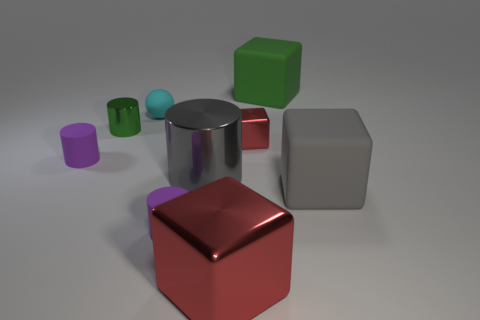What is the cyan object made of?
Keep it short and to the point. Rubber. What number of tiny rubber objects are the same shape as the green metal object?
Provide a short and direct response. 2. What material is the thing that is the same color as the big metallic cylinder?
Offer a terse response. Rubber. Is there anything else that is the same shape as the cyan object?
Provide a short and direct response. No. There is a large cube behind the metal cube behind the small purple rubber object to the left of the tiny rubber sphere; what is its color?
Keep it short and to the point. Green. How many tiny objects are either gray metallic balls or green shiny objects?
Keep it short and to the point. 1. Are there the same number of objects on the left side of the small cyan ball and matte blocks?
Your answer should be very brief. Yes. Are there any cylinders on the right side of the cyan ball?
Give a very brief answer. Yes. What number of metal things are either small purple cubes or big blocks?
Your answer should be compact. 1. There is a large gray cylinder; what number of gray things are on the right side of it?
Provide a short and direct response. 1. 